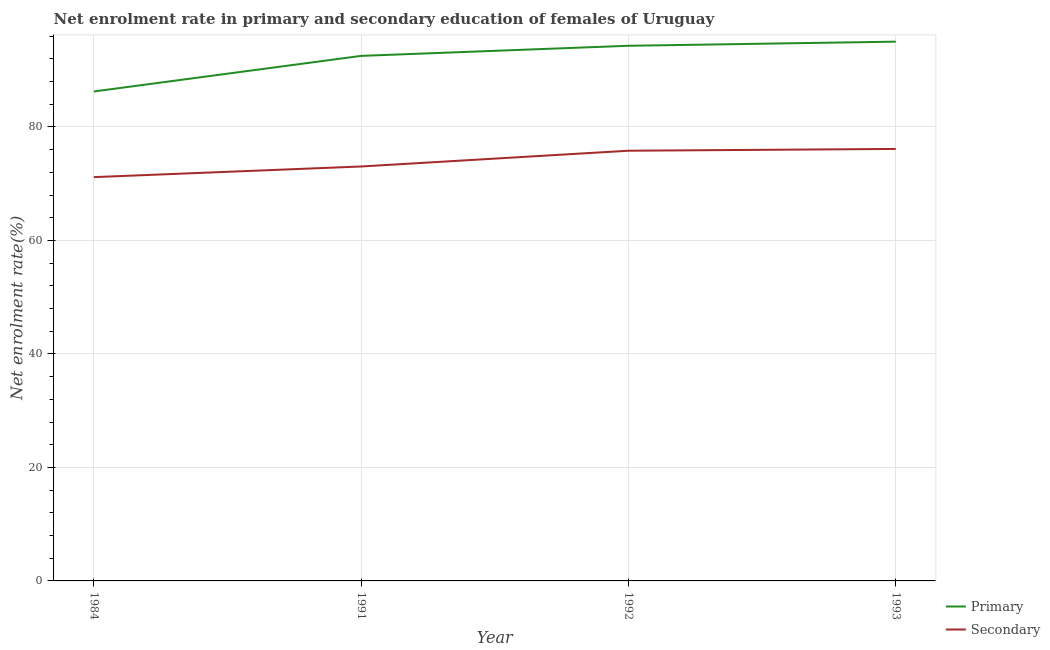Does the line corresponding to enrollment rate in primary education intersect with the line corresponding to enrollment rate in secondary education?
Your answer should be very brief. No. Is the number of lines equal to the number of legend labels?
Provide a short and direct response. Yes. What is the enrollment rate in secondary education in 1984?
Provide a succinct answer. 71.16. Across all years, what is the maximum enrollment rate in secondary education?
Provide a succinct answer. 76.13. Across all years, what is the minimum enrollment rate in primary education?
Ensure brevity in your answer.  86.25. What is the total enrollment rate in primary education in the graph?
Give a very brief answer. 368.12. What is the difference between the enrollment rate in primary education in 1992 and that in 1993?
Offer a very short reply. -0.73. What is the difference between the enrollment rate in secondary education in 1984 and the enrollment rate in primary education in 1993?
Provide a succinct answer. -23.88. What is the average enrollment rate in secondary education per year?
Provide a succinct answer. 74.03. In the year 1984, what is the difference between the enrollment rate in primary education and enrollment rate in secondary education?
Keep it short and to the point. 15.1. In how many years, is the enrollment rate in primary education greater than 36 %?
Your response must be concise. 4. What is the ratio of the enrollment rate in secondary education in 1992 to that in 1993?
Provide a short and direct response. 1. What is the difference between the highest and the second highest enrollment rate in primary education?
Offer a very short reply. 0.73. What is the difference between the highest and the lowest enrollment rate in primary education?
Offer a terse response. 8.78. In how many years, is the enrollment rate in primary education greater than the average enrollment rate in primary education taken over all years?
Keep it short and to the point. 3. Is the sum of the enrollment rate in secondary education in 1984 and 1993 greater than the maximum enrollment rate in primary education across all years?
Keep it short and to the point. Yes. Does the enrollment rate in primary education monotonically increase over the years?
Your answer should be very brief. Yes. Is the enrollment rate in primary education strictly greater than the enrollment rate in secondary education over the years?
Your answer should be compact. Yes. How many years are there in the graph?
Offer a terse response. 4. Are the values on the major ticks of Y-axis written in scientific E-notation?
Provide a short and direct response. No. Does the graph contain any zero values?
Provide a succinct answer. No. Does the graph contain grids?
Provide a succinct answer. Yes. How many legend labels are there?
Give a very brief answer. 2. What is the title of the graph?
Offer a terse response. Net enrolment rate in primary and secondary education of females of Uruguay. What is the label or title of the Y-axis?
Your answer should be very brief. Net enrolment rate(%). What is the Net enrolment rate(%) in Primary in 1984?
Your answer should be very brief. 86.25. What is the Net enrolment rate(%) in Secondary in 1984?
Offer a terse response. 71.16. What is the Net enrolment rate(%) of Primary in 1991?
Provide a short and direct response. 92.53. What is the Net enrolment rate(%) of Secondary in 1991?
Provide a short and direct response. 73.04. What is the Net enrolment rate(%) in Primary in 1992?
Offer a terse response. 94.31. What is the Net enrolment rate(%) in Secondary in 1992?
Offer a terse response. 75.81. What is the Net enrolment rate(%) of Primary in 1993?
Your answer should be very brief. 95.03. What is the Net enrolment rate(%) in Secondary in 1993?
Your answer should be very brief. 76.13. Across all years, what is the maximum Net enrolment rate(%) of Primary?
Your response must be concise. 95.03. Across all years, what is the maximum Net enrolment rate(%) of Secondary?
Your answer should be compact. 76.13. Across all years, what is the minimum Net enrolment rate(%) of Primary?
Ensure brevity in your answer.  86.25. Across all years, what is the minimum Net enrolment rate(%) in Secondary?
Keep it short and to the point. 71.16. What is the total Net enrolment rate(%) in Primary in the graph?
Your response must be concise. 368.12. What is the total Net enrolment rate(%) of Secondary in the graph?
Provide a succinct answer. 296.14. What is the difference between the Net enrolment rate(%) of Primary in 1984 and that in 1991?
Give a very brief answer. -6.27. What is the difference between the Net enrolment rate(%) in Secondary in 1984 and that in 1991?
Ensure brevity in your answer.  -1.88. What is the difference between the Net enrolment rate(%) of Primary in 1984 and that in 1992?
Your answer should be very brief. -8.05. What is the difference between the Net enrolment rate(%) in Secondary in 1984 and that in 1992?
Offer a very short reply. -4.65. What is the difference between the Net enrolment rate(%) in Primary in 1984 and that in 1993?
Keep it short and to the point. -8.78. What is the difference between the Net enrolment rate(%) in Secondary in 1984 and that in 1993?
Keep it short and to the point. -4.97. What is the difference between the Net enrolment rate(%) in Primary in 1991 and that in 1992?
Make the answer very short. -1.78. What is the difference between the Net enrolment rate(%) in Secondary in 1991 and that in 1992?
Your response must be concise. -2.78. What is the difference between the Net enrolment rate(%) in Primary in 1991 and that in 1993?
Your answer should be compact. -2.51. What is the difference between the Net enrolment rate(%) in Secondary in 1991 and that in 1993?
Keep it short and to the point. -3.09. What is the difference between the Net enrolment rate(%) in Primary in 1992 and that in 1993?
Make the answer very short. -0.73. What is the difference between the Net enrolment rate(%) of Secondary in 1992 and that in 1993?
Offer a terse response. -0.31. What is the difference between the Net enrolment rate(%) in Primary in 1984 and the Net enrolment rate(%) in Secondary in 1991?
Your answer should be very brief. 13.22. What is the difference between the Net enrolment rate(%) in Primary in 1984 and the Net enrolment rate(%) in Secondary in 1992?
Offer a very short reply. 10.44. What is the difference between the Net enrolment rate(%) in Primary in 1984 and the Net enrolment rate(%) in Secondary in 1993?
Offer a very short reply. 10.13. What is the difference between the Net enrolment rate(%) in Primary in 1991 and the Net enrolment rate(%) in Secondary in 1992?
Offer a very short reply. 16.71. What is the difference between the Net enrolment rate(%) in Primary in 1991 and the Net enrolment rate(%) in Secondary in 1993?
Your answer should be very brief. 16.4. What is the difference between the Net enrolment rate(%) in Primary in 1992 and the Net enrolment rate(%) in Secondary in 1993?
Ensure brevity in your answer.  18.18. What is the average Net enrolment rate(%) in Primary per year?
Make the answer very short. 92.03. What is the average Net enrolment rate(%) in Secondary per year?
Keep it short and to the point. 74.03. In the year 1984, what is the difference between the Net enrolment rate(%) of Primary and Net enrolment rate(%) of Secondary?
Offer a terse response. 15.1. In the year 1991, what is the difference between the Net enrolment rate(%) in Primary and Net enrolment rate(%) in Secondary?
Your response must be concise. 19.49. In the year 1992, what is the difference between the Net enrolment rate(%) in Primary and Net enrolment rate(%) in Secondary?
Your response must be concise. 18.49. In the year 1993, what is the difference between the Net enrolment rate(%) of Primary and Net enrolment rate(%) of Secondary?
Offer a very short reply. 18.91. What is the ratio of the Net enrolment rate(%) of Primary in 1984 to that in 1991?
Keep it short and to the point. 0.93. What is the ratio of the Net enrolment rate(%) in Secondary in 1984 to that in 1991?
Your answer should be compact. 0.97. What is the ratio of the Net enrolment rate(%) of Primary in 1984 to that in 1992?
Provide a succinct answer. 0.91. What is the ratio of the Net enrolment rate(%) in Secondary in 1984 to that in 1992?
Provide a short and direct response. 0.94. What is the ratio of the Net enrolment rate(%) of Primary in 1984 to that in 1993?
Provide a succinct answer. 0.91. What is the ratio of the Net enrolment rate(%) of Secondary in 1984 to that in 1993?
Give a very brief answer. 0.93. What is the ratio of the Net enrolment rate(%) in Primary in 1991 to that in 1992?
Provide a short and direct response. 0.98. What is the ratio of the Net enrolment rate(%) in Secondary in 1991 to that in 1992?
Keep it short and to the point. 0.96. What is the ratio of the Net enrolment rate(%) of Primary in 1991 to that in 1993?
Provide a short and direct response. 0.97. What is the ratio of the Net enrolment rate(%) in Secondary in 1991 to that in 1993?
Offer a very short reply. 0.96. What is the ratio of the Net enrolment rate(%) in Secondary in 1992 to that in 1993?
Offer a terse response. 1. What is the difference between the highest and the second highest Net enrolment rate(%) in Primary?
Give a very brief answer. 0.73. What is the difference between the highest and the second highest Net enrolment rate(%) of Secondary?
Make the answer very short. 0.31. What is the difference between the highest and the lowest Net enrolment rate(%) in Primary?
Keep it short and to the point. 8.78. What is the difference between the highest and the lowest Net enrolment rate(%) of Secondary?
Your answer should be compact. 4.97. 